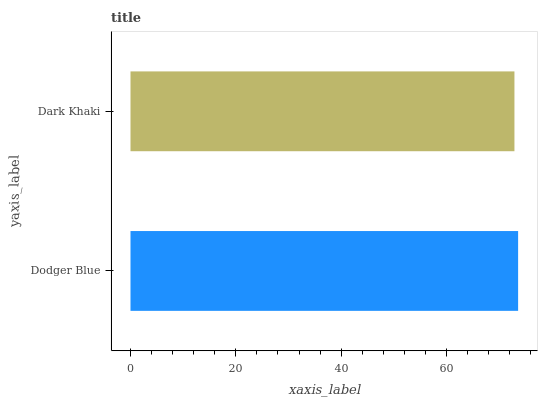Is Dark Khaki the minimum?
Answer yes or no. Yes. Is Dodger Blue the maximum?
Answer yes or no. Yes. Is Dark Khaki the maximum?
Answer yes or no. No. Is Dodger Blue greater than Dark Khaki?
Answer yes or no. Yes. Is Dark Khaki less than Dodger Blue?
Answer yes or no. Yes. Is Dark Khaki greater than Dodger Blue?
Answer yes or no. No. Is Dodger Blue less than Dark Khaki?
Answer yes or no. No. Is Dodger Blue the high median?
Answer yes or no. Yes. Is Dark Khaki the low median?
Answer yes or no. Yes. Is Dark Khaki the high median?
Answer yes or no. No. Is Dodger Blue the low median?
Answer yes or no. No. 